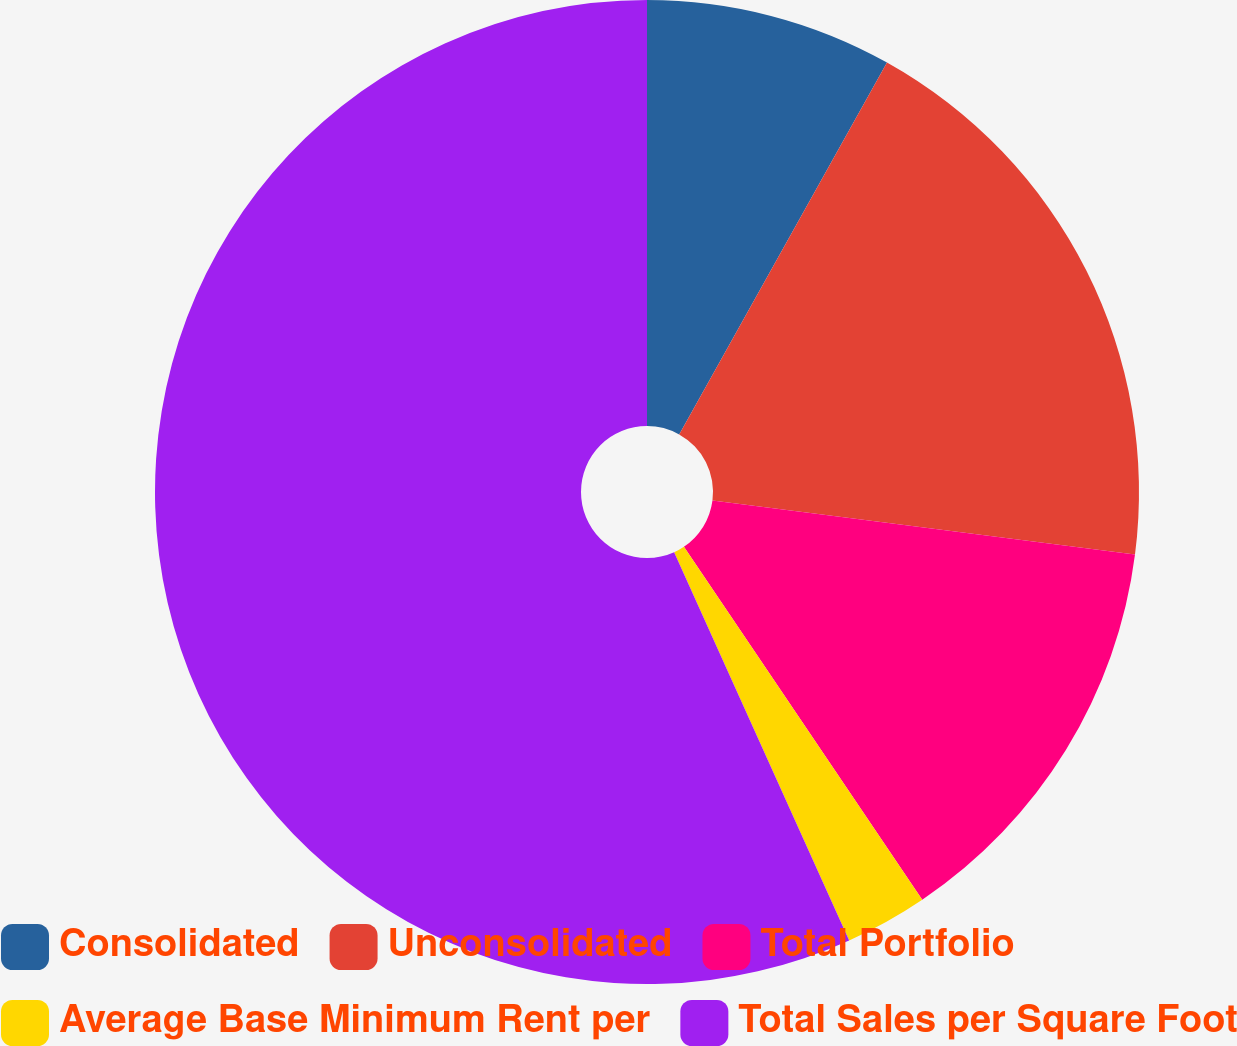<chart> <loc_0><loc_0><loc_500><loc_500><pie_chart><fcel>Consolidated<fcel>Unconsolidated<fcel>Total Portfolio<fcel>Average Base Minimum Rent per<fcel>Total Sales per Square Foot<nl><fcel>8.11%<fcel>18.92%<fcel>13.52%<fcel>2.71%<fcel>56.74%<nl></chart> 